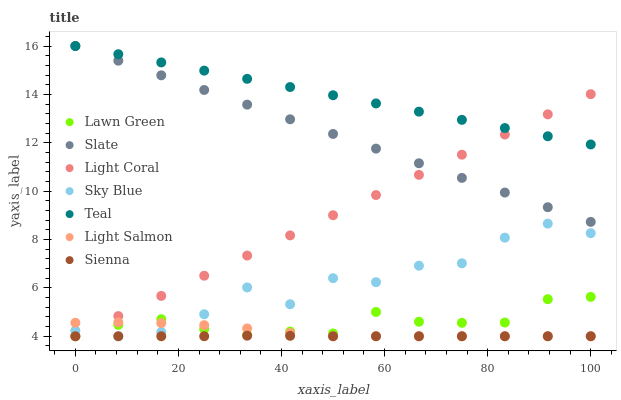Does Sienna have the minimum area under the curve?
Answer yes or no. Yes. Does Teal have the maximum area under the curve?
Answer yes or no. Yes. Does Light Salmon have the minimum area under the curve?
Answer yes or no. No. Does Light Salmon have the maximum area under the curve?
Answer yes or no. No. Is Teal the smoothest?
Answer yes or no. Yes. Is Sky Blue the roughest?
Answer yes or no. Yes. Is Light Salmon the smoothest?
Answer yes or no. No. Is Light Salmon the roughest?
Answer yes or no. No. Does Lawn Green have the lowest value?
Answer yes or no. Yes. Does Slate have the lowest value?
Answer yes or no. No. Does Teal have the highest value?
Answer yes or no. Yes. Does Light Salmon have the highest value?
Answer yes or no. No. Is Sky Blue less than Slate?
Answer yes or no. Yes. Is Teal greater than Sienna?
Answer yes or no. Yes. Does Lawn Green intersect Sienna?
Answer yes or no. Yes. Is Lawn Green less than Sienna?
Answer yes or no. No. Is Lawn Green greater than Sienna?
Answer yes or no. No. Does Sky Blue intersect Slate?
Answer yes or no. No. 